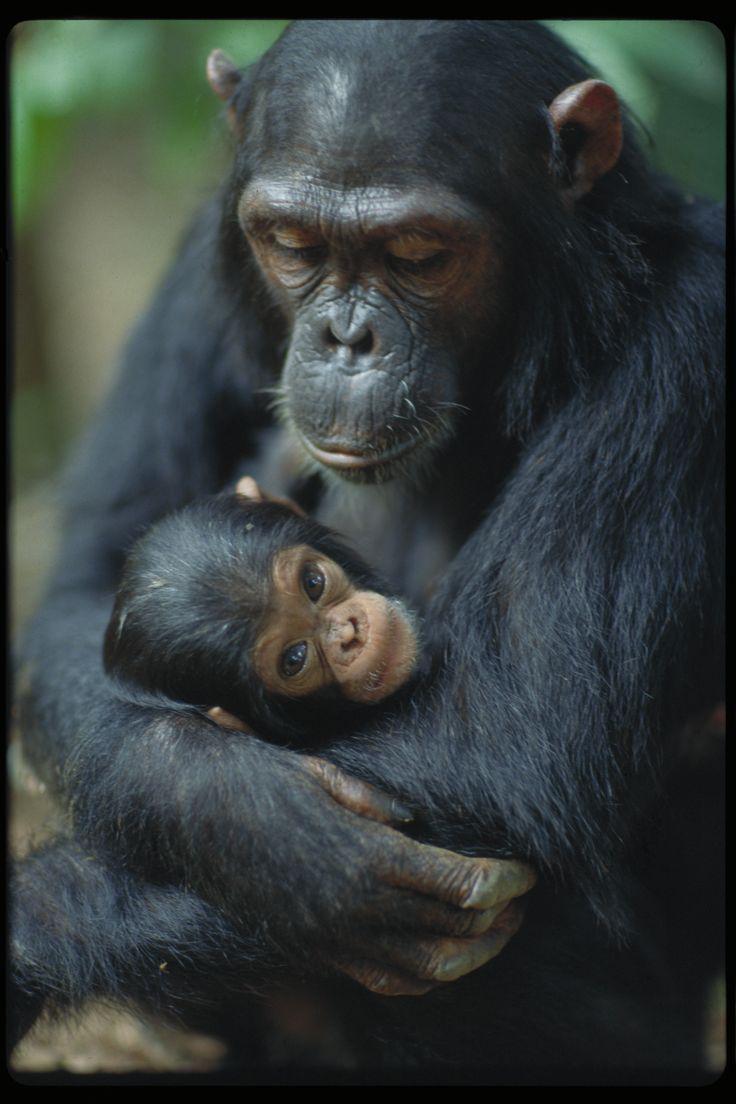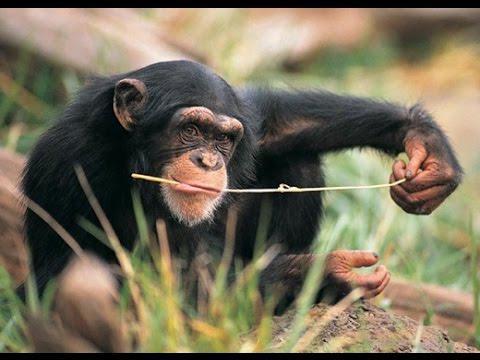The first image is the image on the left, the second image is the image on the right. For the images displayed, is the sentence "One monkey is holding another in one of the images." factually correct? Answer yes or no. Yes. 